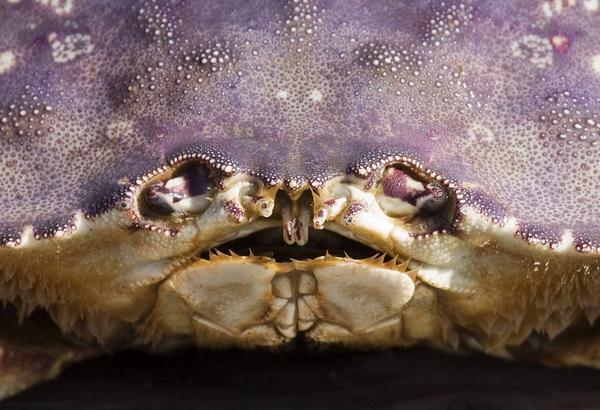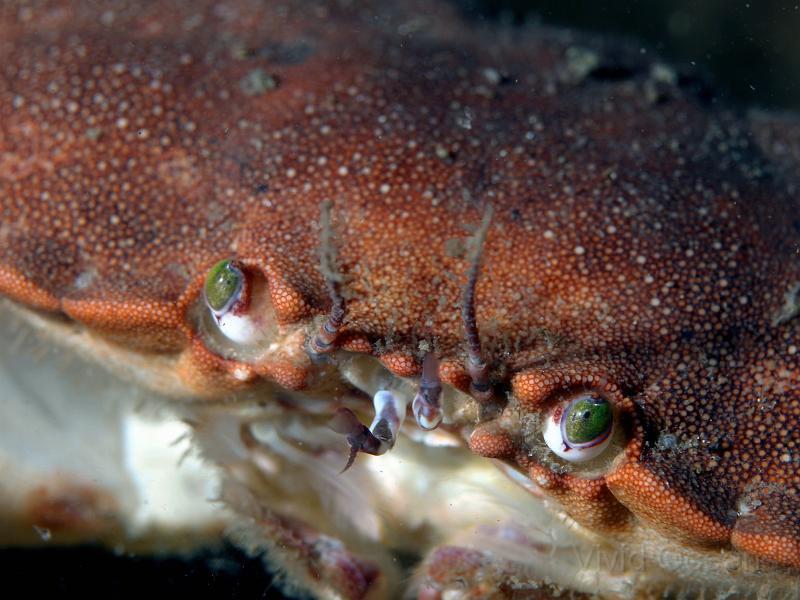The first image is the image on the left, the second image is the image on the right. Evaluate the accuracy of this statement regarding the images: "One image shows the underside of a crab, and the other image shows a face-forward crab with eyes visible.". Is it true? Answer yes or no. No. The first image is the image on the left, the second image is the image on the right. Considering the images on both sides, is "In one of the images, the underbelly of a crab is shown." valid? Answer yes or no. No. 